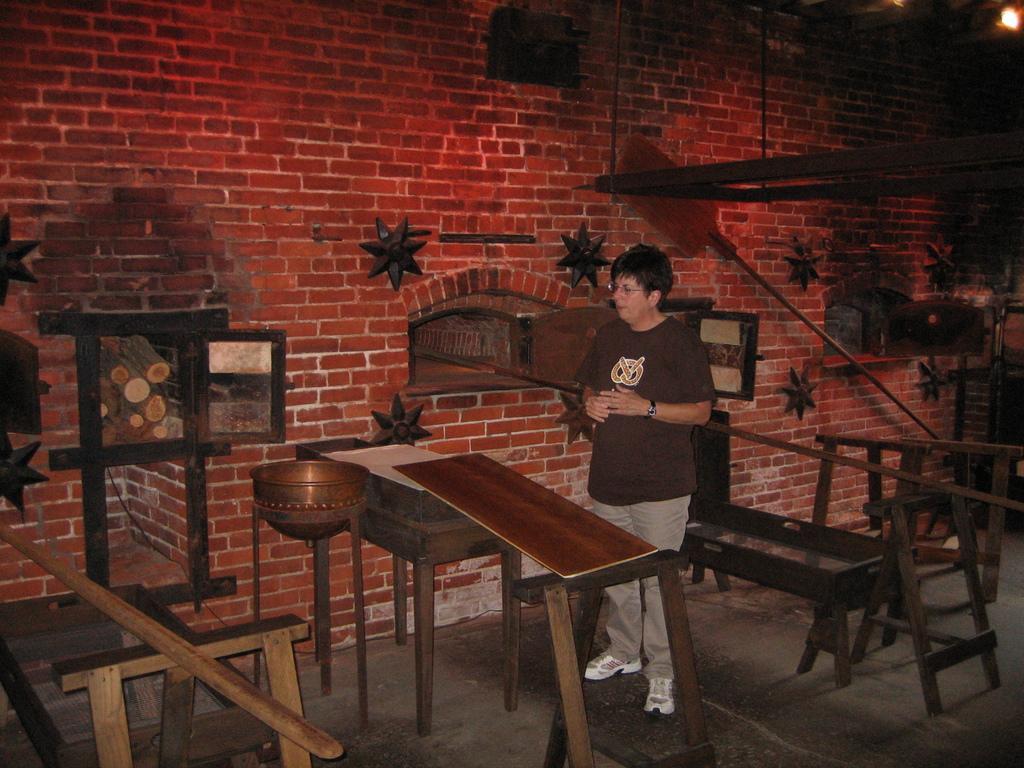Can you describe this image briefly? in this picture we can a person standing in front of the table and back side also there are so many tables which side we can see the wall which contains with breaks. 